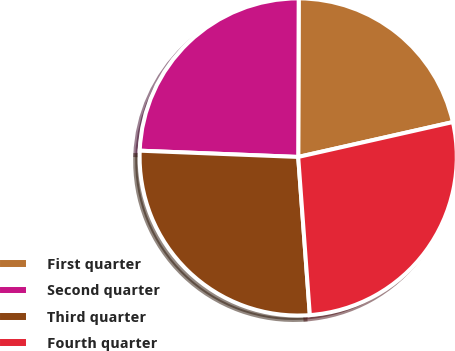Convert chart to OTSL. <chart><loc_0><loc_0><loc_500><loc_500><pie_chart><fcel>First quarter<fcel>Second quarter<fcel>Third quarter<fcel>Fourth quarter<nl><fcel>21.42%<fcel>24.42%<fcel>26.8%<fcel>27.36%<nl></chart> 